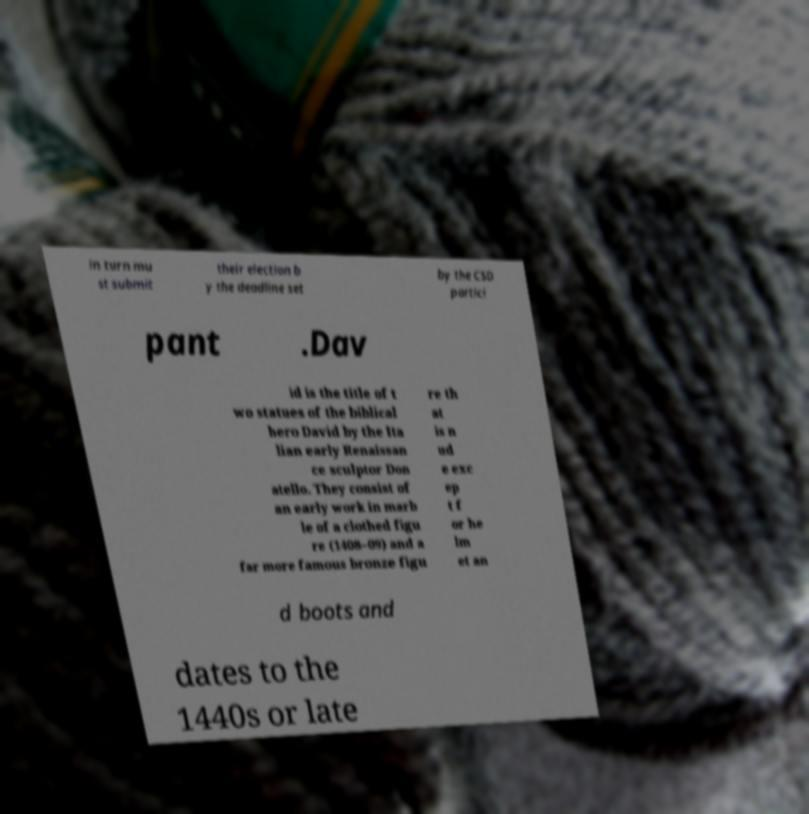Could you assist in decoding the text presented in this image and type it out clearly? in turn mu st submit their election b y the deadline set by the CSD partici pant .Dav id is the title of t wo statues of the biblical hero David by the Ita lian early Renaissan ce sculptor Don atello. They consist of an early work in marb le of a clothed figu re (1408–09) and a far more famous bronze figu re th at is n ud e exc ep t f or he lm et an d boots and dates to the 1440s or late 